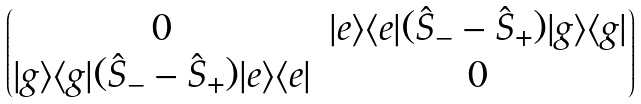<formula> <loc_0><loc_0><loc_500><loc_500>\begin{pmatrix} 0 & | e \rangle \langle e | ( \hat { S } _ { - } - \hat { S } _ { + } ) | g \rangle \langle g | \\ | g \rangle \langle g | ( \hat { S } _ { - } - \hat { S } _ { + } ) | e \rangle \langle e | & 0 \\ \end{pmatrix}</formula> 